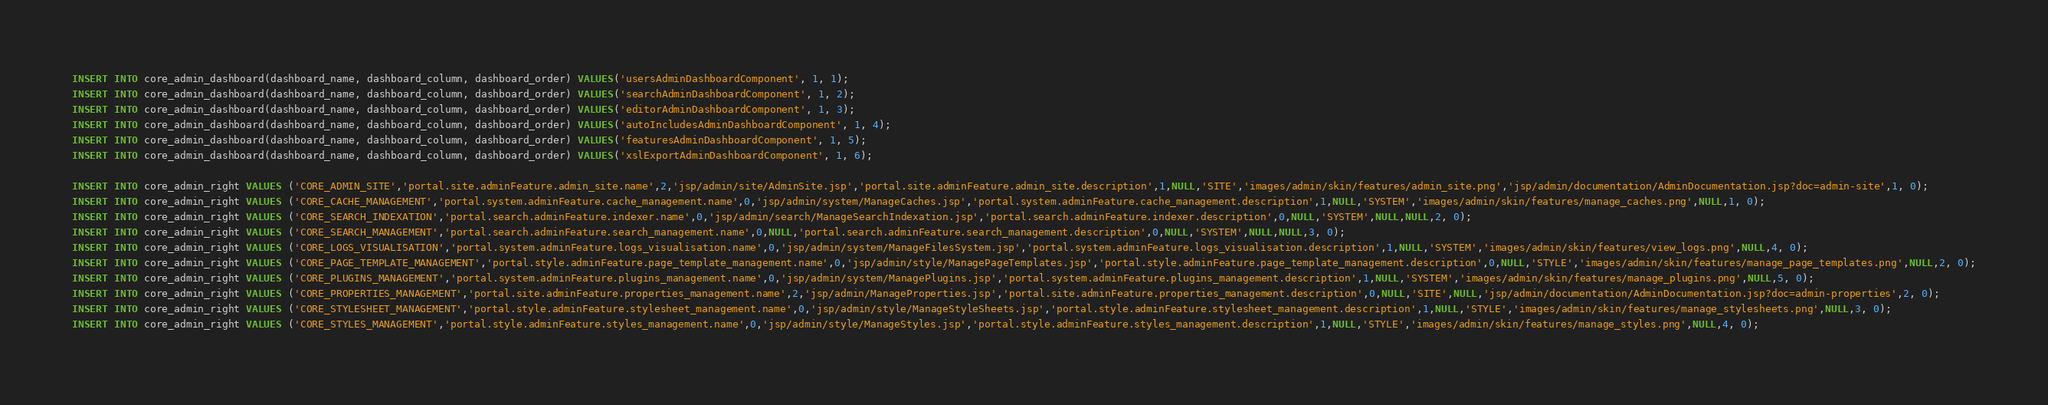Convert code to text. <code><loc_0><loc_0><loc_500><loc_500><_SQL_>INSERT INTO core_admin_dashboard(dashboard_name, dashboard_column, dashboard_order) VALUES('usersAdminDashboardComponent', 1, 1);
INSERT INTO core_admin_dashboard(dashboard_name, dashboard_column, dashboard_order) VALUES('searchAdminDashboardComponent', 1, 2);
INSERT INTO core_admin_dashboard(dashboard_name, dashboard_column, dashboard_order) VALUES('editorAdminDashboardComponent', 1, 3);
INSERT INTO core_admin_dashboard(dashboard_name, dashboard_column, dashboard_order) VALUES('autoIncludesAdminDashboardComponent', 1, 4);
INSERT INTO core_admin_dashboard(dashboard_name, dashboard_column, dashboard_order) VALUES('featuresAdminDashboardComponent', 1, 5);
INSERT INTO core_admin_dashboard(dashboard_name, dashboard_column, dashboard_order) VALUES('xslExportAdminDashboardComponent', 1, 6);

INSERT INTO core_admin_right VALUES ('CORE_ADMIN_SITE','portal.site.adminFeature.admin_site.name',2,'jsp/admin/site/AdminSite.jsp','portal.site.adminFeature.admin_site.description',1,NULL,'SITE','images/admin/skin/features/admin_site.png','jsp/admin/documentation/AdminDocumentation.jsp?doc=admin-site',1, 0);
INSERT INTO core_admin_right VALUES ('CORE_CACHE_MANAGEMENT','portal.system.adminFeature.cache_management.name',0,'jsp/admin/system/ManageCaches.jsp','portal.system.adminFeature.cache_management.description',1,NULL,'SYSTEM','images/admin/skin/features/manage_caches.png',NULL,1, 0);
INSERT INTO core_admin_right VALUES ('CORE_SEARCH_INDEXATION','portal.search.adminFeature.indexer.name',0,'jsp/admin/search/ManageSearchIndexation.jsp','portal.search.adminFeature.indexer.description',0,NULL,'SYSTEM',NULL,NULL,2, 0);
INSERT INTO core_admin_right VALUES ('CORE_SEARCH_MANAGEMENT','portal.search.adminFeature.search_management.name',0,NULL,'portal.search.adminFeature.search_management.description',0,NULL,'SYSTEM',NULL,NULL,3, 0);
INSERT INTO core_admin_right VALUES ('CORE_LOGS_VISUALISATION','portal.system.adminFeature.logs_visualisation.name',0,'jsp/admin/system/ManageFilesSystem.jsp','portal.system.adminFeature.logs_visualisation.description',1,NULL,'SYSTEM','images/admin/skin/features/view_logs.png',NULL,4, 0);
INSERT INTO core_admin_right VALUES ('CORE_PAGE_TEMPLATE_MANAGEMENT','portal.style.adminFeature.page_template_management.name',0,'jsp/admin/style/ManagePageTemplates.jsp','portal.style.adminFeature.page_template_management.description',0,NULL,'STYLE','images/admin/skin/features/manage_page_templates.png',NULL,2, 0);
INSERT INTO core_admin_right VALUES ('CORE_PLUGINS_MANAGEMENT','portal.system.adminFeature.plugins_management.name',0,'jsp/admin/system/ManagePlugins.jsp','portal.system.adminFeature.plugins_management.description',1,NULL,'SYSTEM','images/admin/skin/features/manage_plugins.png',NULL,5, 0);
INSERT INTO core_admin_right VALUES ('CORE_PROPERTIES_MANAGEMENT','portal.site.adminFeature.properties_management.name',2,'jsp/admin/ManageProperties.jsp','portal.site.adminFeature.properties_management.description',0,NULL,'SITE',NULL,'jsp/admin/documentation/AdminDocumentation.jsp?doc=admin-properties',2, 0);
INSERT INTO core_admin_right VALUES ('CORE_STYLESHEET_MANAGEMENT','portal.style.adminFeature.stylesheet_management.name',0,'jsp/admin/style/ManageStyleSheets.jsp','portal.style.adminFeature.stylesheet_management.description',1,NULL,'STYLE','images/admin/skin/features/manage_stylesheets.png',NULL,3, 0);
INSERT INTO core_admin_right VALUES ('CORE_STYLES_MANAGEMENT','portal.style.adminFeature.styles_management.name',0,'jsp/admin/style/ManageStyles.jsp','portal.style.adminFeature.styles_management.description',1,NULL,'STYLE','images/admin/skin/features/manage_styles.png',NULL,4, 0);</code> 